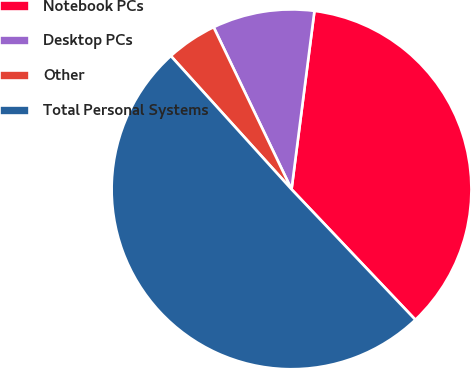<chart> <loc_0><loc_0><loc_500><loc_500><pie_chart><fcel>Notebook PCs<fcel>Desktop PCs<fcel>Other<fcel>Total Personal Systems<nl><fcel>35.88%<fcel>9.16%<fcel>4.58%<fcel>50.38%<nl></chart> 